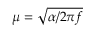<formula> <loc_0><loc_0><loc_500><loc_500>\mu = \sqrt { \alpha / 2 \pi f }</formula> 